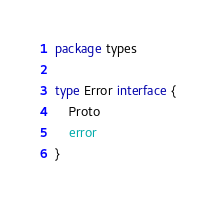Convert code to text. <code><loc_0><loc_0><loc_500><loc_500><_Go_>package types

type Error interface {
	Proto
	error
}</code> 